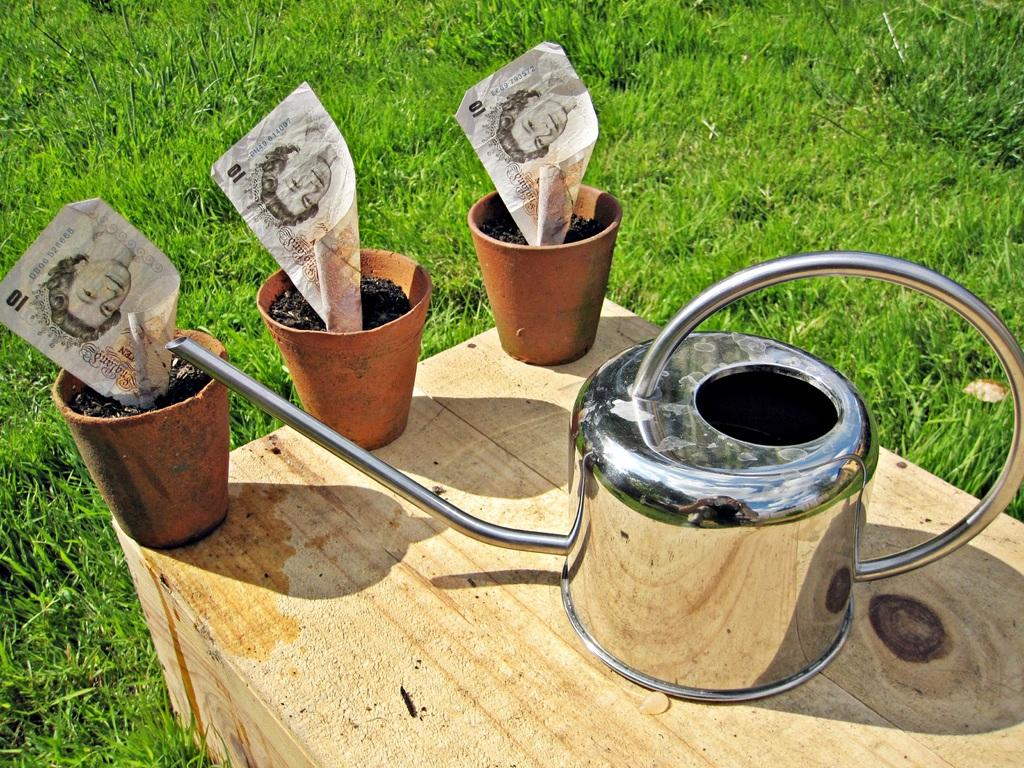What is the main object in the center of the image? There is a table in the center of the image. What is placed on the table? There is a vessel, pots, charcoal, and papers on the table. What can be seen in the background of the image? There is grass visible in the background of the image. How does the account balance change during the earthquake in the image? There is no account or earthquake mentioned in the image; it features a table with various objects on it and a grassy background. 